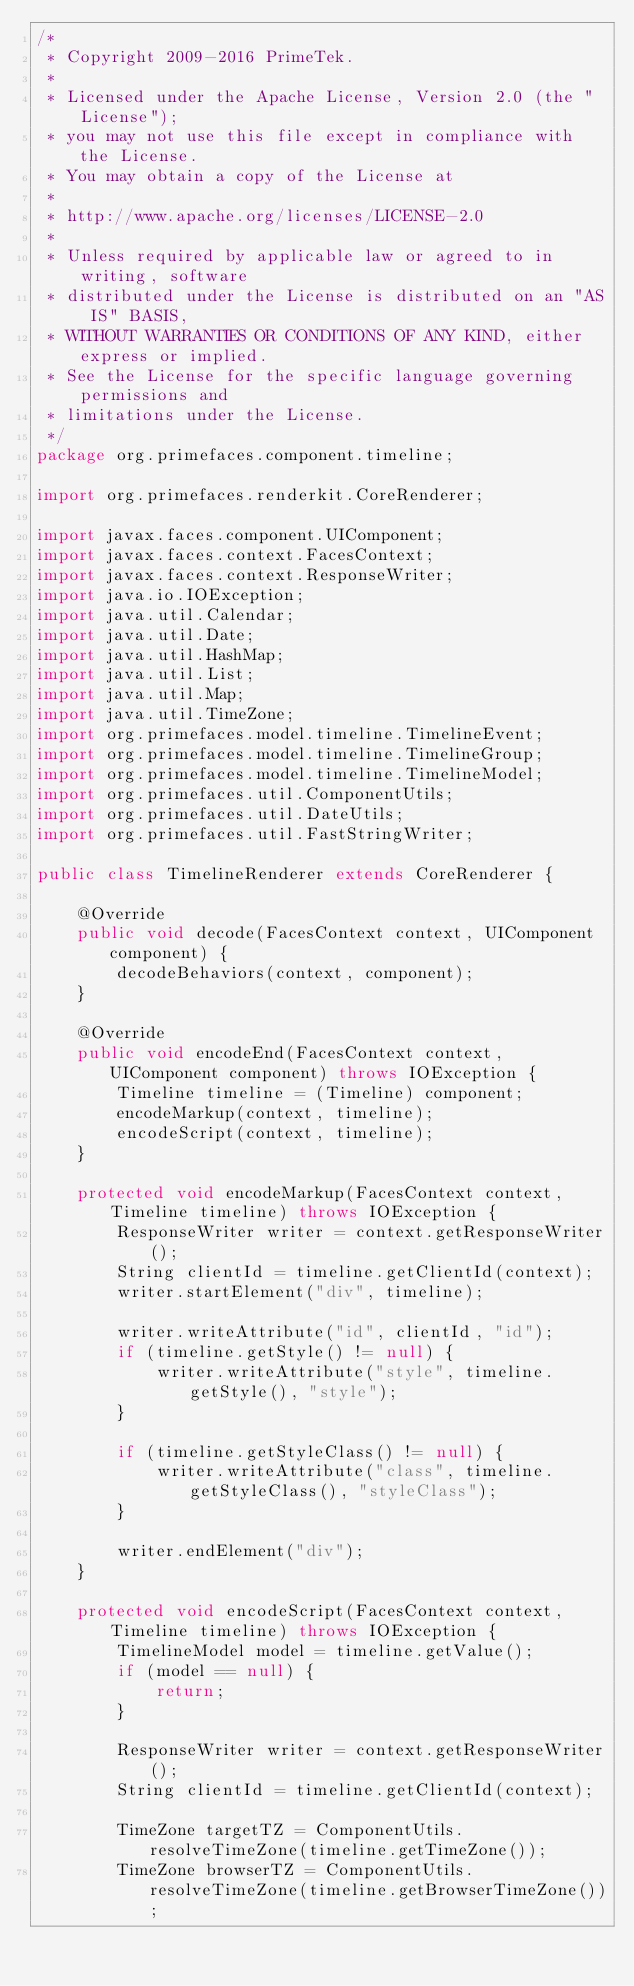<code> <loc_0><loc_0><loc_500><loc_500><_Java_>/*
 * Copyright 2009-2016 PrimeTek.
 *
 * Licensed under the Apache License, Version 2.0 (the "License");
 * you may not use this file except in compliance with the License.
 * You may obtain a copy of the License at
 *
 * http://www.apache.org/licenses/LICENSE-2.0
 *
 * Unless required by applicable law or agreed to in writing, software
 * distributed under the License is distributed on an "AS IS" BASIS,
 * WITHOUT WARRANTIES OR CONDITIONS OF ANY KIND, either express or implied.
 * See the License for the specific language governing permissions and
 * limitations under the License.
 */
package org.primefaces.component.timeline;

import org.primefaces.renderkit.CoreRenderer;

import javax.faces.component.UIComponent;
import javax.faces.context.FacesContext;
import javax.faces.context.ResponseWriter;
import java.io.IOException;
import java.util.Calendar;
import java.util.Date;
import java.util.HashMap;
import java.util.List;
import java.util.Map;
import java.util.TimeZone;
import org.primefaces.model.timeline.TimelineEvent;
import org.primefaces.model.timeline.TimelineGroup;
import org.primefaces.model.timeline.TimelineModel;
import org.primefaces.util.ComponentUtils;
import org.primefaces.util.DateUtils;
import org.primefaces.util.FastStringWriter;

public class TimelineRenderer extends CoreRenderer {

    @Override
    public void decode(FacesContext context, UIComponent component) {
        decodeBehaviors(context, component);
    }

    @Override
    public void encodeEnd(FacesContext context, UIComponent component) throws IOException {
        Timeline timeline = (Timeline) component;
        encodeMarkup(context, timeline);
        encodeScript(context, timeline);
    }

    protected void encodeMarkup(FacesContext context, Timeline timeline) throws IOException {
        ResponseWriter writer = context.getResponseWriter();
        String clientId = timeline.getClientId(context);
        writer.startElement("div", timeline);

        writer.writeAttribute("id", clientId, "id");
        if (timeline.getStyle() != null) {
            writer.writeAttribute("style", timeline.getStyle(), "style");
        }

        if (timeline.getStyleClass() != null) {
            writer.writeAttribute("class", timeline.getStyleClass(), "styleClass");
        }

        writer.endElement("div");
    }

    protected void encodeScript(FacesContext context, Timeline timeline) throws IOException {
        TimelineModel model = timeline.getValue();
        if (model == null) {
            return;
        }

        ResponseWriter writer = context.getResponseWriter();
        String clientId = timeline.getClientId(context);

        TimeZone targetTZ = ComponentUtils.resolveTimeZone(timeline.getTimeZone());
        TimeZone browserTZ = ComponentUtils.resolveTimeZone(timeline.getBrowserTimeZone());
</code> 